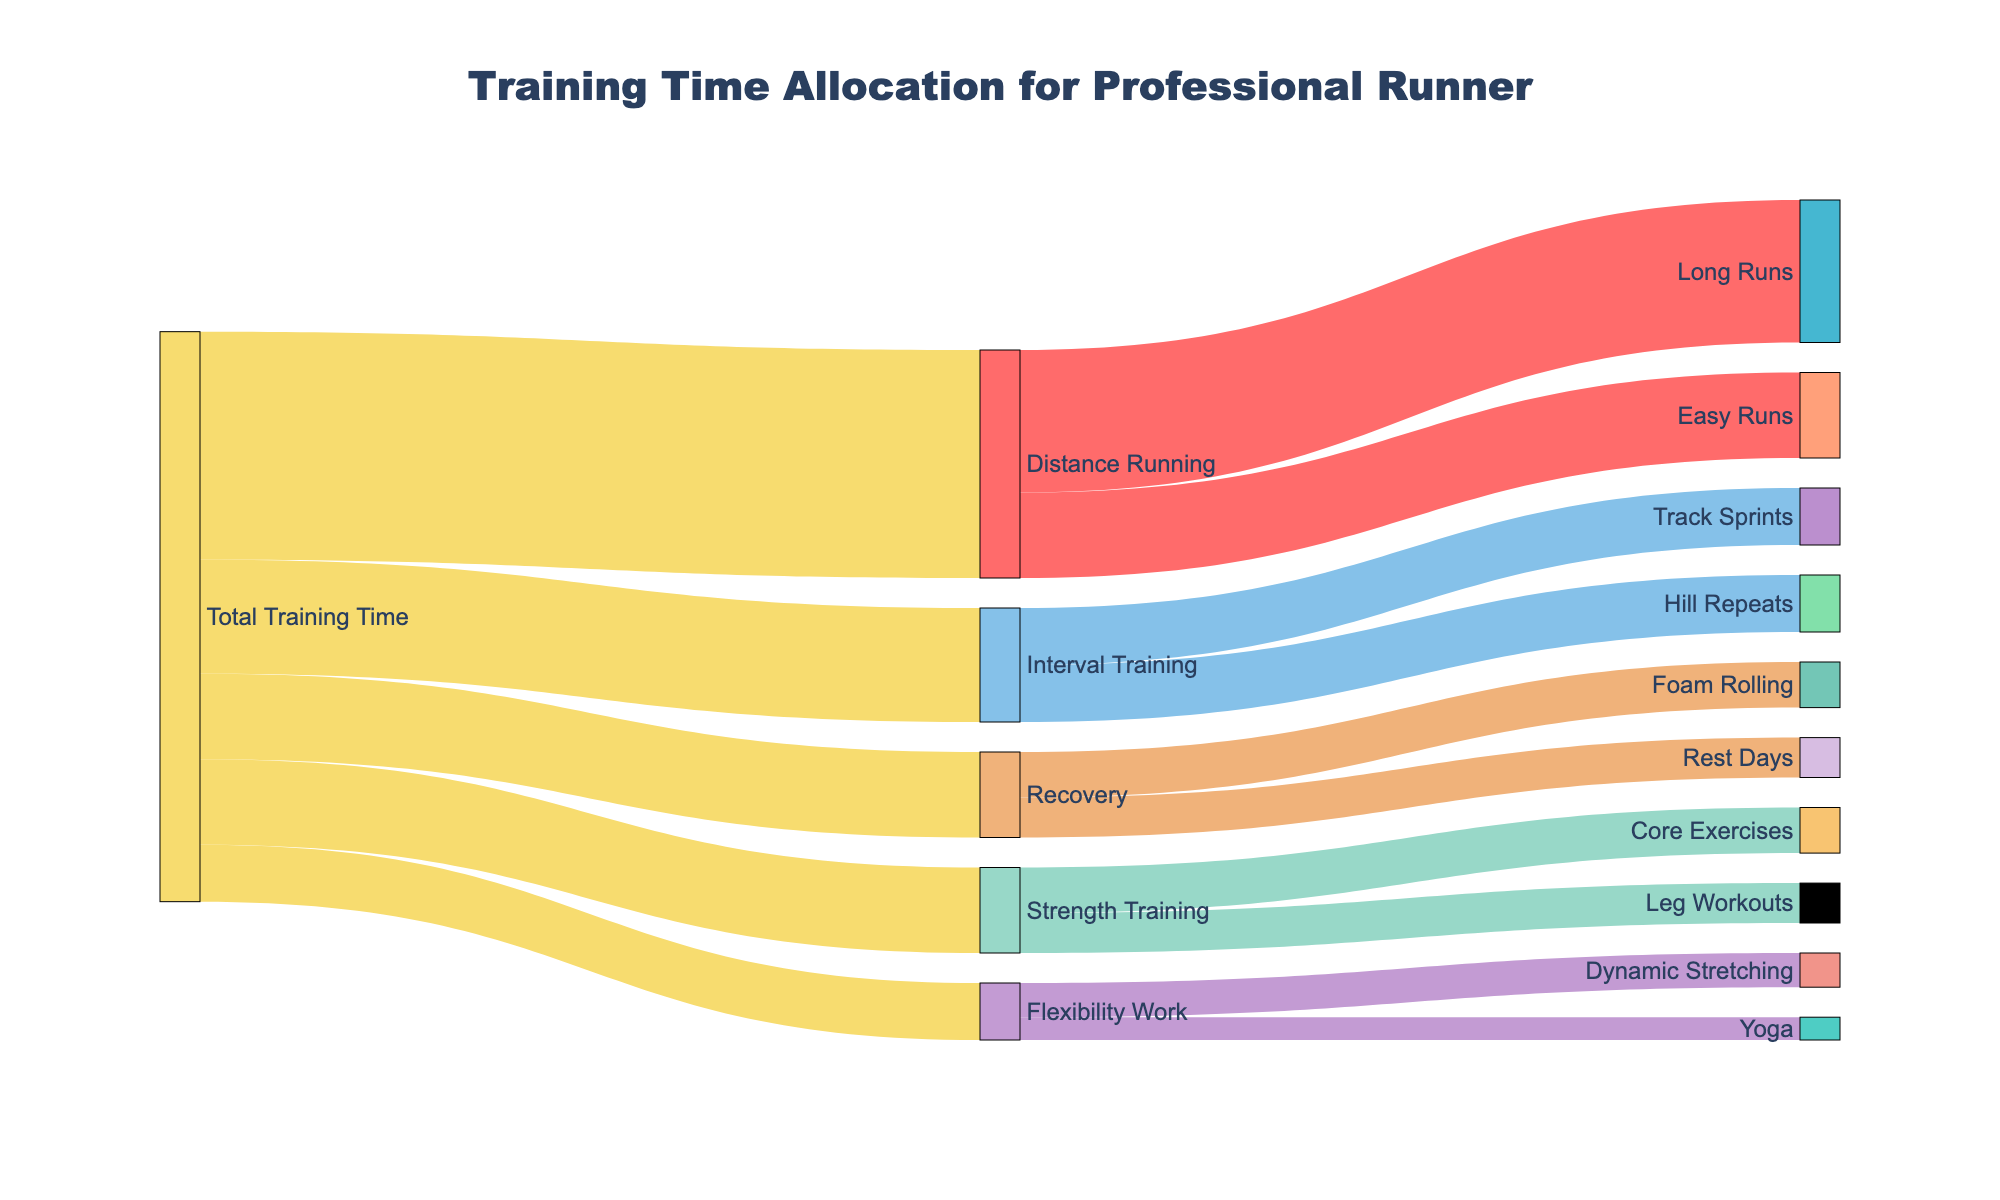What's the total percentage of training time allocated to Distance Running? To find the percentage, divide the time spent on Distance Running (40 units) by the Total Training Time (100 units). Thus, (40/100)*100 = 40%.
Answer: 40% How does the time allocated for Interval Training compare to Strength Training? Interval Training is allocated 20 units, while Strength Training has 15 units. Interval Training has 5 more units than Strength Training.
Answer: Interval Training has 5 more units What is the combined training time for Core Exercises and Leg Workouts? Core Exercises take up 8 units and Leg Workouts take 7 units. Adding them together gives 8 + 7 = 15 units.
Answer: 15 units Which specific training activity within Recovery has more allocated time? Recovery includes Foam Rolling (8 units) and Rest Days (7 units). Foam Rolling has more units.
Answer: Foam Rolling What percentage of the total training time is allocated to Recovery activities? Recovery takes up 15 units. The Total Training Time is 100 units. Therefore, (15/100)*100 = 15%.
Answer: 15% Among Flexibility Work activities, which is allocated less time, Dynamic Stretching or Yoga? Flexibility Work includes Dynamic Stretching (6 units) and Yoga (4 units). Yoga is allocated less time.
Answer: Yoga What is the total allocated training time for all activities related to Distance Running? Distance Running activities include Long Runs (25 units) and Easy Runs (15 units). Adding them gives 25 + 15 = 40 units.
Answer: 40 units How much more time is allocated to Long Runs compared to Hill Repeats? Long Runs have 25 units and Hill Repeats have 10 units. The difference is 25 - 10 = 15 units.
Answer: 15 units Which overall training category has the smallest allocation of time? Among Total Training Time distributions, Flexibility Work has the smallest allocation of 10 units.
Answer: Flexibility Work What is the percentage allocation of time between Core Exercises and Leg Workouts within Strength Training? Core Exercises take 8 units and Leg Workouts take 7 units. The total for Strength Training is 15 units. Core Exercises: (8/15)*100 ≈ 53.33%, Leg Workouts: (7/15)*100 ≈ 46.67%.
Answer: Core Exercises: 53.33%, Leg Workouts: 46.67% 